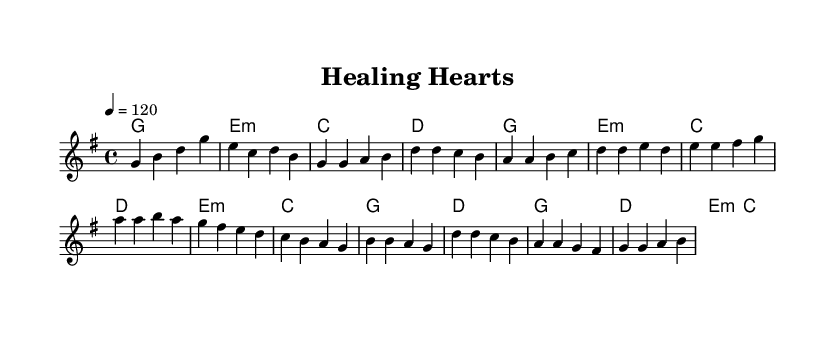What is the key signature of this music? The piece is in G major, which is indicated by one sharp.
Answer: G major What is the time signature of this music? The time signature is 4/4, meaning there are four beats in each measure.
Answer: 4/4 What is the tempo marking for this piece? The tempo is set to 120 beats per minute, indicated by "4 = 120".
Answer: 120 How many measures are in the verse section? The verse contains four measures based on the melody notation provided.
Answer: 4 What is the chord for the first measure of the chorus? The first measure of the chorus uses a G major chord, as indicated in the harmonies section.
Answer: G Which section of the music features the melody that first goes up to the note 'b'? The first occurrence of the note 'b' in the melody is in the verse section.
Answer: Verse What theme do the lyrics of this piece likely explore based on its title? The title "Healing Hearts" suggests themes of hope and help, focusing on making a difference in people's lives.
Answer: Helping others 